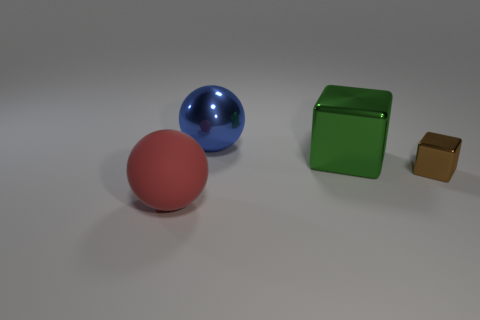Add 4 large blue matte cubes. How many objects exist? 8 Subtract 0 blue blocks. How many objects are left? 4 Subtract all matte spheres. Subtract all big blue metal balls. How many objects are left? 2 Add 1 brown metal things. How many brown metal things are left? 2 Add 3 green objects. How many green objects exist? 4 